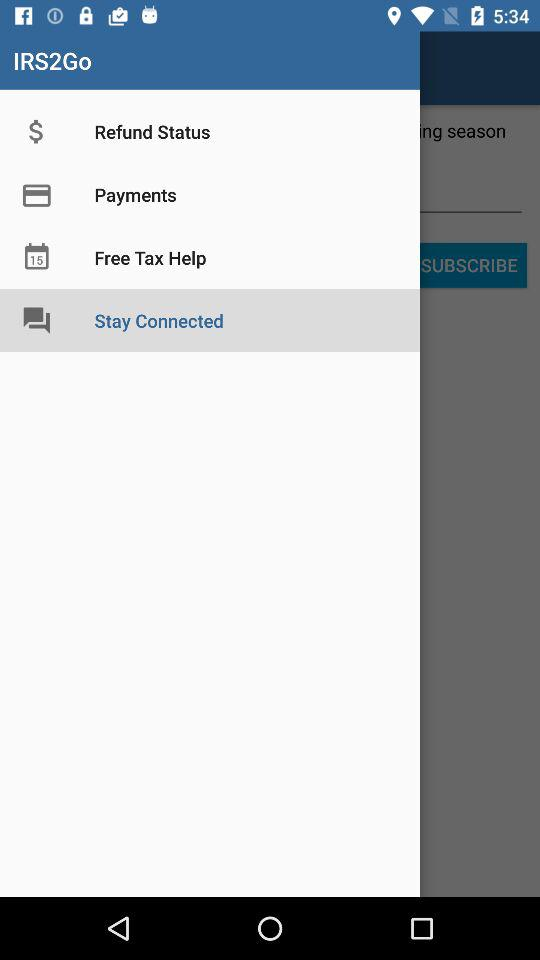What is the application name? The application name is "IRS2Go". 